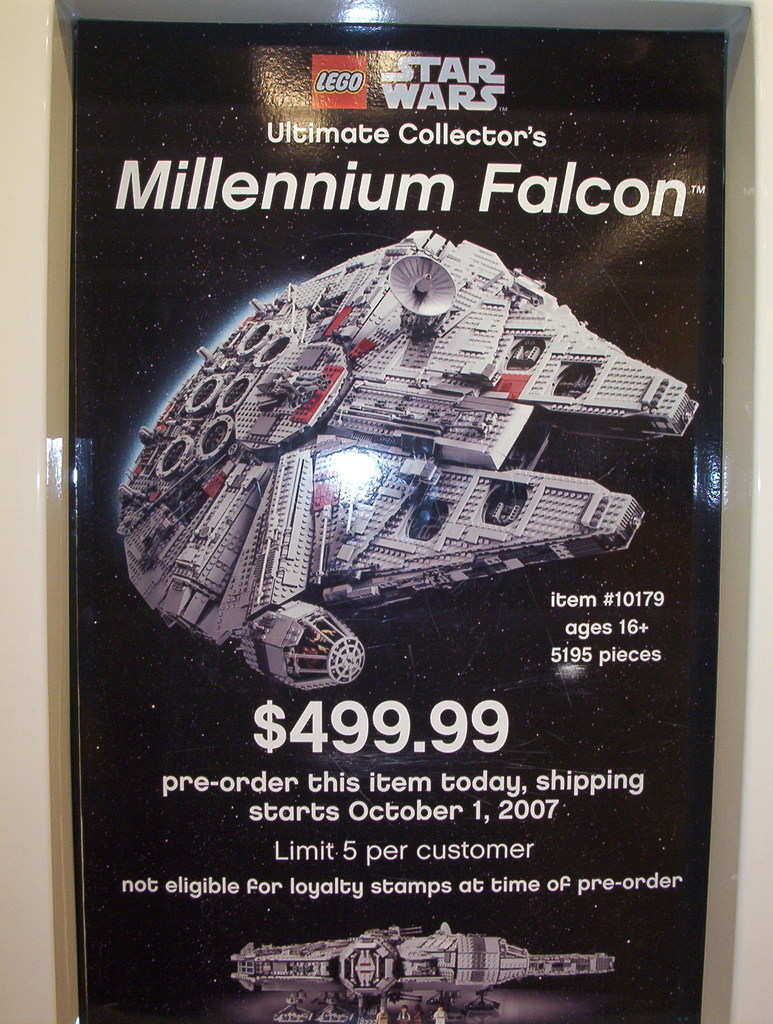Are there special edition LEGO sets like this? Yes, this is part of the LEGO Ultimate Collector’s Series, which includes large and highly detailed sets designed more for display than regular play. These sets are often rare, targeted at adult fans, and include models of iconic vehicles and scenes from various franchises such as Star Wars. 